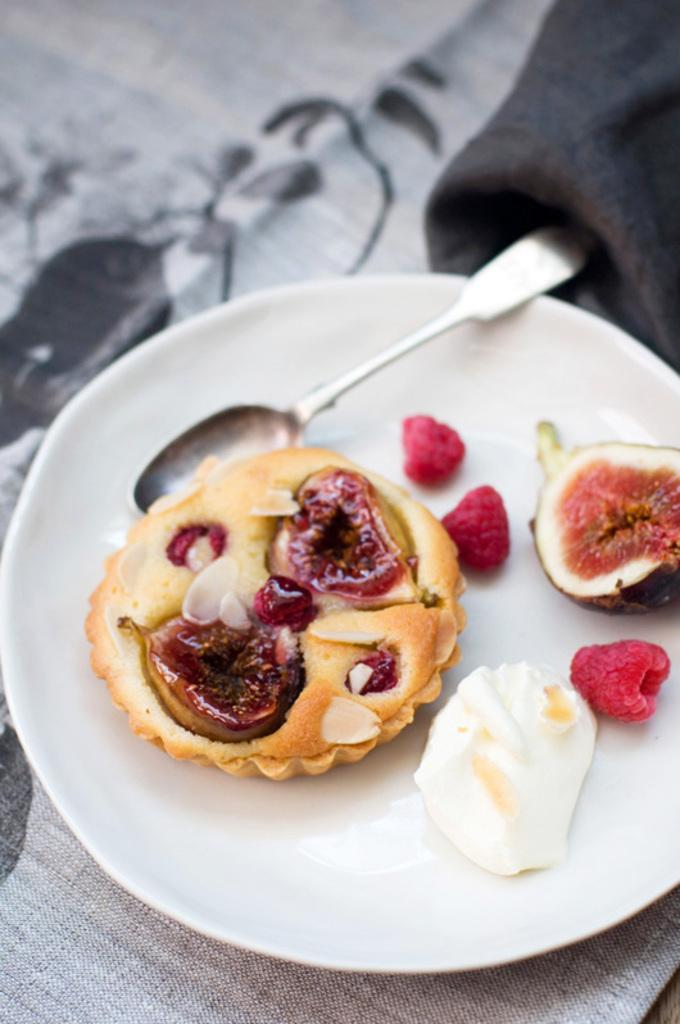What type of food can be seen in the image? There is food in the image, including fruits. What utensil is present in the image? There is a spoon in the image. Where is the spoon located? The spoon is on a white plate. What is the color of the tablecloth in the image? The white plate is on a grey tablecloth. What is the cause of the protest happening in the image? There is no protest present in the image; it only features food, fruits, a spoon, a white plate, and a grey tablecloth. 